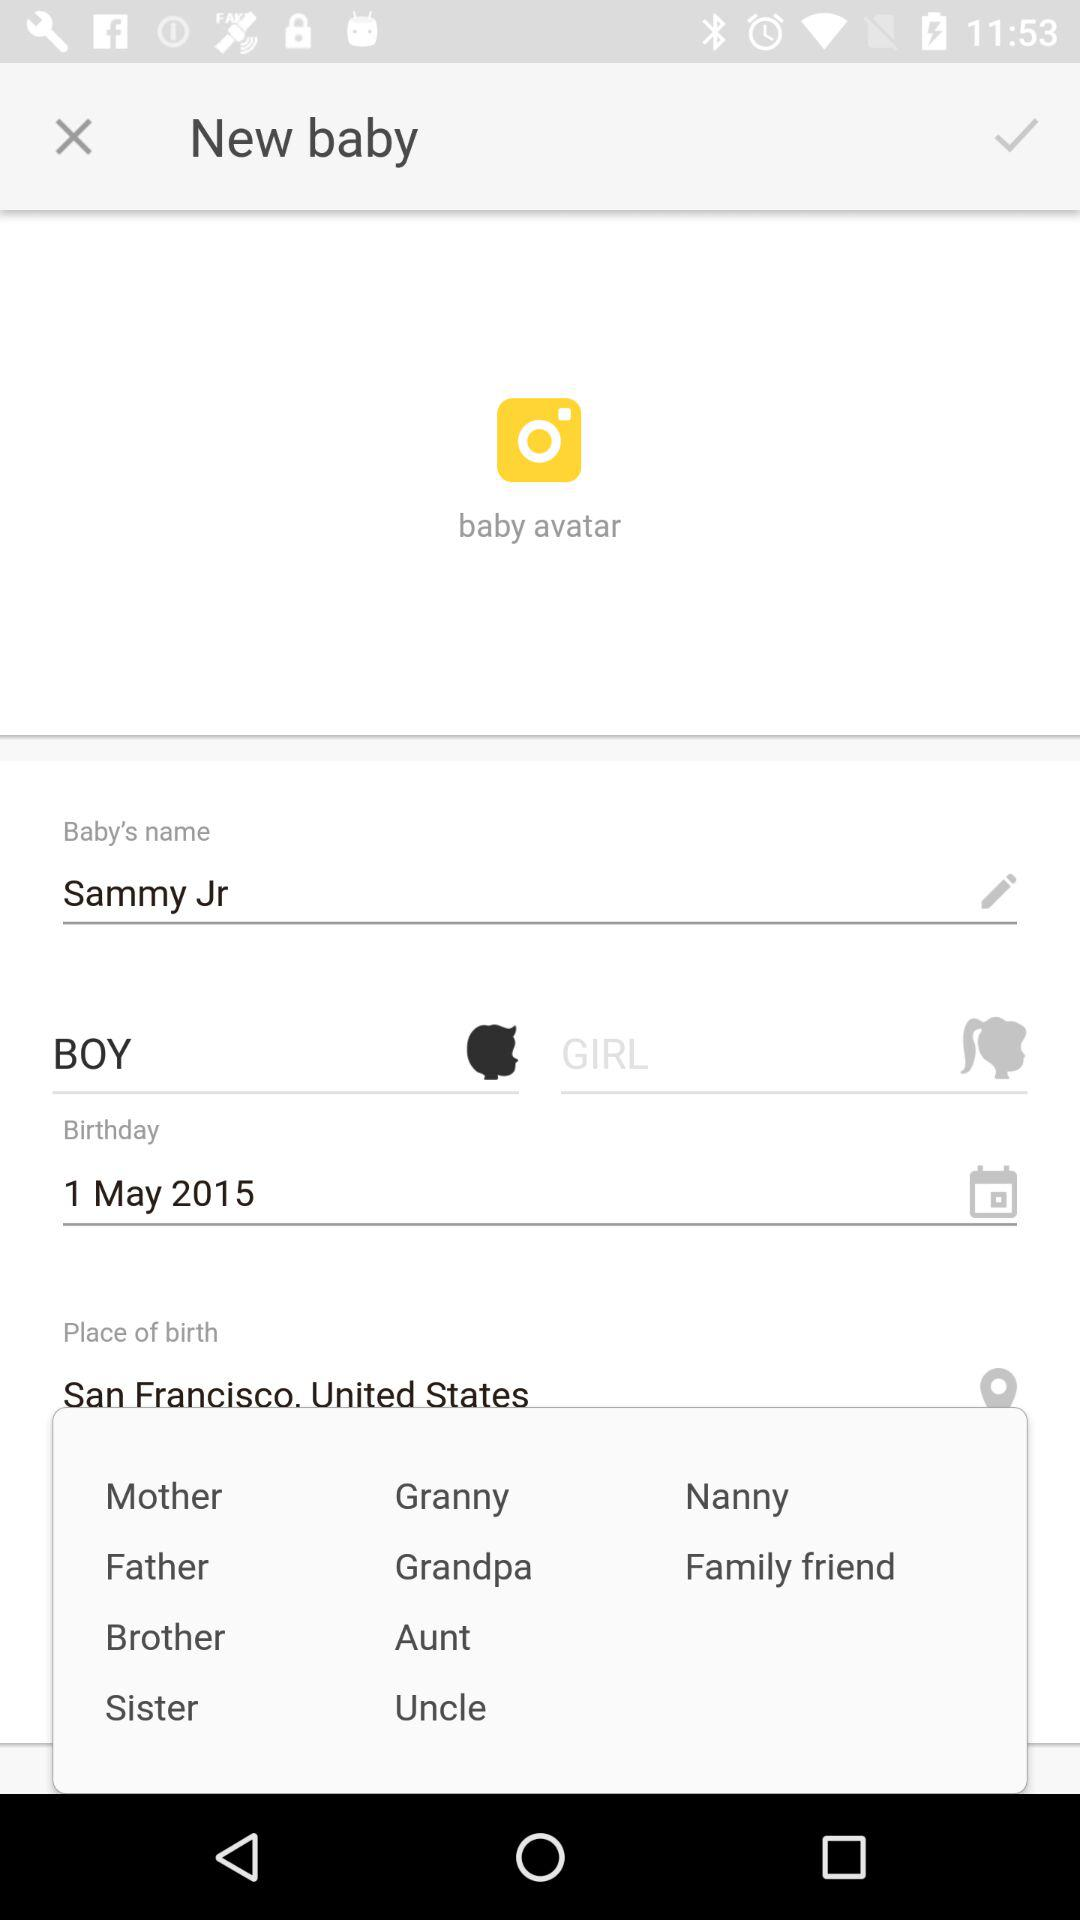What is the date of birth? The date of birth is May 1, 2015. 